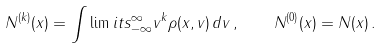Convert formula to latex. <formula><loc_0><loc_0><loc_500><loc_500>N ^ { ( k ) } ( x ) = \int \lim i t s _ { - \infty } ^ { \infty } v ^ { k } \rho ( x , v ) \, d v \, , \quad N ^ { ( 0 ) } ( x ) = N ( x ) \, .</formula> 